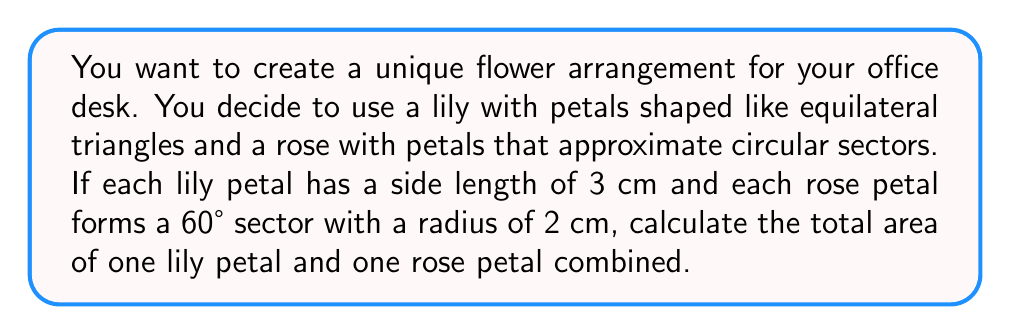What is the answer to this math problem? Let's approach this problem step by step:

1. Calculate the area of the lily petal (equilateral triangle):
   - For an equilateral triangle with side length $s$, the area is given by:
     $$A_{triangle} = \frac{\sqrt{3}}{4}s^2$$
   - Substituting $s = 3$ cm:
     $$A_{lily} = \frac{\sqrt{3}}{4}(3^2) = \frac{9\sqrt{3}}{4} \approx 3.90 \text{ cm}^2$$

2. Calculate the area of the rose petal (circular sector):
   - For a circular sector with radius $r$ and central angle $\theta$ in radians, the area is:
     $$A_{sector} = \frac{1}{2}r^2\theta$$
   - Convert 60° to radians: $\theta = 60° \times \frac{\pi}{180°} = \frac{\pi}{3}$
   - Substituting $r = 2$ cm and $\theta = \frac{\pi}{3}$:
     $$A_{rose} = \frac{1}{2}(2^2)(\frac{\pi}{3}) = \frac{2\pi}{3} \approx 2.09 \text{ cm}^2$$

3. Calculate the total area:
   $$A_{total} = A_{lily} + A_{rose} = \frac{9\sqrt{3}}{4} + \frac{2\pi}{3}$$

[asy]
import geometry;

// Lily petal (equilateral triangle)
pair A = (0,0), B = (3,0), C = (1.5, 1.5*sqrt(3));
draw(A--B--C--cycle, blue);

// Rose petal (circular sector)
pair O = (5,0);
draw(arc(O, 2, 0, 60), red);
draw(O--(O+(2,0)), red);
draw(O--(O+(cos(pi/3), sin(pi/3))*2), red);

label("Lily petal", (1.5,-0.5), blue);
label("Rose petal", (6,1), red);
[/asy]
Answer: $$\frac{9\sqrt{3}}{4} + \frac{2\pi}{3} \text{ cm}^2$$ 